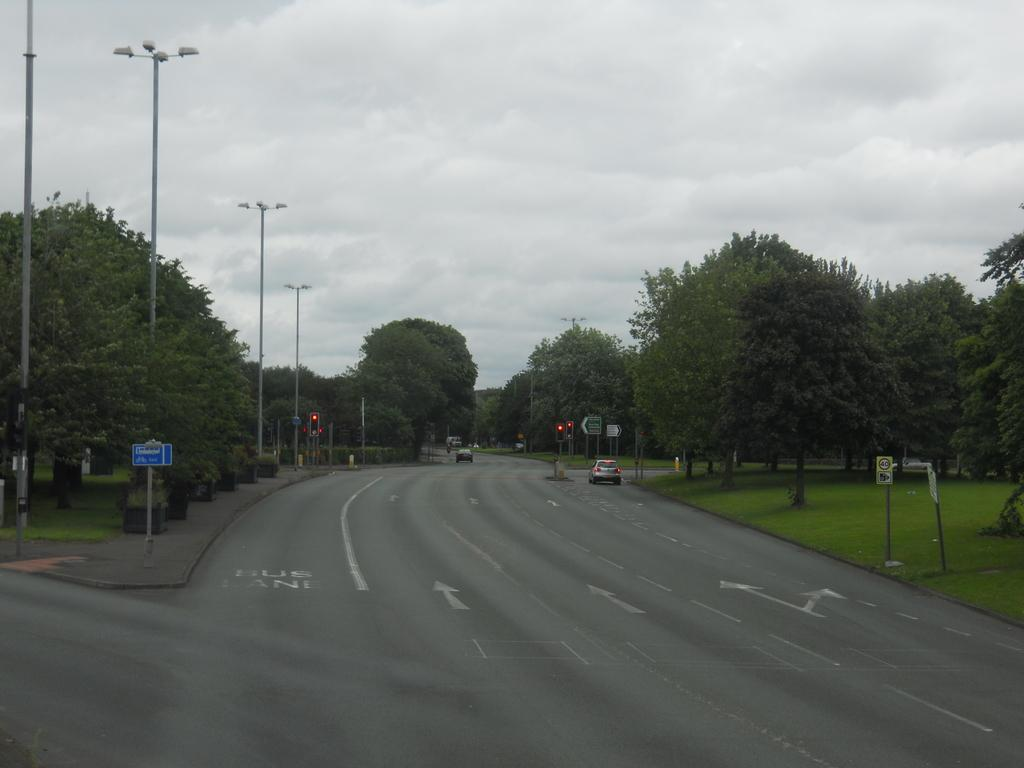What type of infrastructure can be seen in the image? There are roads in the image. What is moving along the roads in the image? Vehicles are present in the image. What are some objects that are supporting the infrastructure in the image? There are poles in the image. What helps regulate the flow of traffic in the image? Signal lights are visible in the image. What provides information or directions in the image? Sign boards are present in the image. What type of natural environment is visible in the image? The ground with grass is visible in the image, and trees are present in the image. What part of the sky is visible in the image? The sky with clouds is visible in the image. Can you tell me how many beggars are visible in the image? There are no beggars present in the image. What type of minister is shown giving a speech in the image? There is no minister or speech present in the image. 